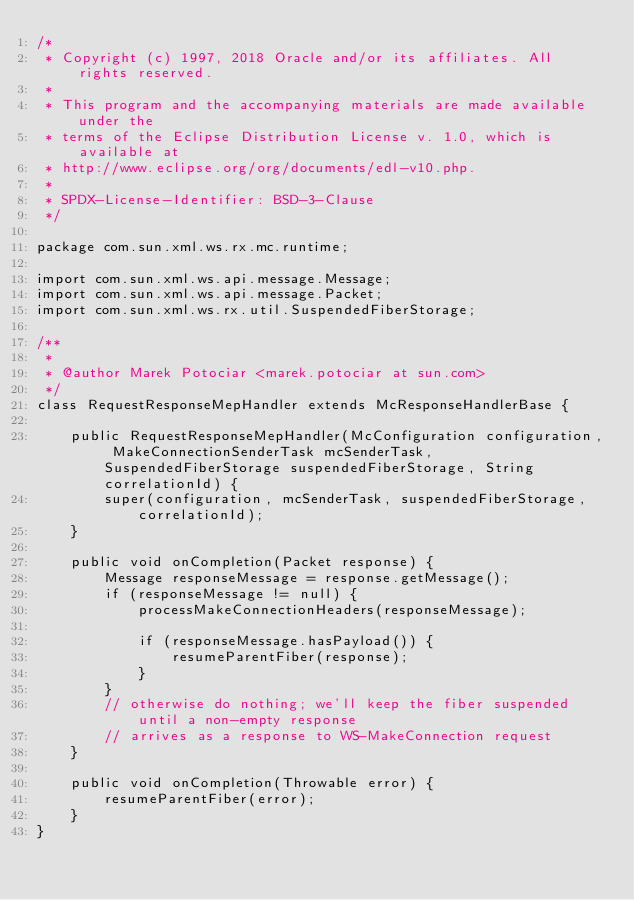Convert code to text. <code><loc_0><loc_0><loc_500><loc_500><_Java_>/*
 * Copyright (c) 1997, 2018 Oracle and/or its affiliates. All rights reserved.
 *
 * This program and the accompanying materials are made available under the
 * terms of the Eclipse Distribution License v. 1.0, which is available at
 * http://www.eclipse.org/org/documents/edl-v10.php.
 *
 * SPDX-License-Identifier: BSD-3-Clause
 */

package com.sun.xml.ws.rx.mc.runtime;

import com.sun.xml.ws.api.message.Message;
import com.sun.xml.ws.api.message.Packet;
import com.sun.xml.ws.rx.util.SuspendedFiberStorage;

/**
 *
 * @author Marek Potociar <marek.potociar at sun.com>
 */
class RequestResponseMepHandler extends McResponseHandlerBase {

    public RequestResponseMepHandler(McConfiguration configuration, MakeConnectionSenderTask mcSenderTask, SuspendedFiberStorage suspendedFiberStorage, String correlationId) {
        super(configuration, mcSenderTask, suspendedFiberStorage, correlationId);
    }

    public void onCompletion(Packet response) {
        Message responseMessage = response.getMessage();
        if (responseMessage != null) {
            processMakeConnectionHeaders(responseMessage);

            if (responseMessage.hasPayload()) {
                resumeParentFiber(response);
            }
        }
        // otherwise do nothing; we'll keep the fiber suspended until a non-empty response
        // arrives as a response to WS-MakeConnection request
    }

    public void onCompletion(Throwable error) {
        resumeParentFiber(error);
    }
}
</code> 